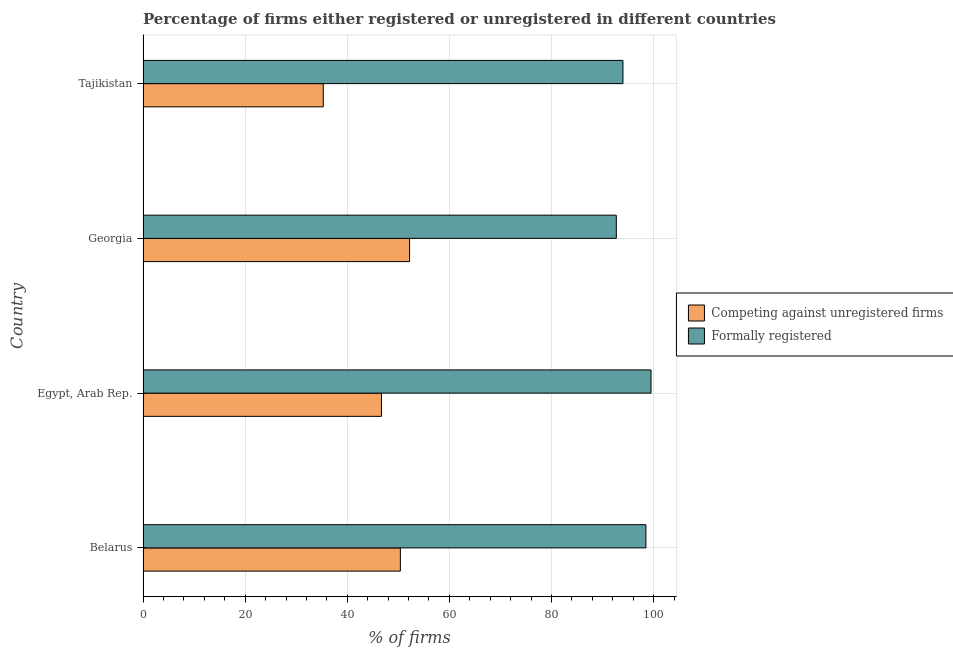How many different coloured bars are there?
Make the answer very short. 2. How many groups of bars are there?
Your answer should be very brief. 4. Are the number of bars per tick equal to the number of legend labels?
Provide a succinct answer. Yes. What is the label of the 1st group of bars from the top?
Ensure brevity in your answer.  Tajikistan. What is the percentage of registered firms in Egypt, Arab Rep.?
Your response must be concise. 46.7. Across all countries, what is the maximum percentage of registered firms?
Keep it short and to the point. 52.2. Across all countries, what is the minimum percentage of formally registered firms?
Provide a short and direct response. 92.7. In which country was the percentage of formally registered firms maximum?
Your answer should be very brief. Egypt, Arab Rep. In which country was the percentage of formally registered firms minimum?
Provide a succinct answer. Georgia. What is the total percentage of registered firms in the graph?
Your answer should be compact. 184.6. What is the difference between the percentage of registered firms in Belarus and that in Tajikistan?
Your answer should be very brief. 15.1. What is the difference between the percentage of formally registered firms in Tajikistan and the percentage of registered firms in Belarus?
Give a very brief answer. 43.6. What is the average percentage of registered firms per country?
Provide a succinct answer. 46.15. What is the difference between the percentage of registered firms and percentage of formally registered firms in Egypt, Arab Rep.?
Offer a terse response. -52.8. In how many countries, is the percentage of formally registered firms greater than 48 %?
Provide a short and direct response. 4. What is the ratio of the percentage of formally registered firms in Belarus to that in Georgia?
Keep it short and to the point. 1.06. Is the percentage of formally registered firms in Egypt, Arab Rep. less than that in Tajikistan?
Offer a very short reply. No. What is the difference between the highest and the lowest percentage of formally registered firms?
Your answer should be compact. 6.8. In how many countries, is the percentage of formally registered firms greater than the average percentage of formally registered firms taken over all countries?
Provide a short and direct response. 2. Is the sum of the percentage of registered firms in Belarus and Georgia greater than the maximum percentage of formally registered firms across all countries?
Provide a succinct answer. Yes. What does the 2nd bar from the top in Belarus represents?
Ensure brevity in your answer.  Competing against unregistered firms. What does the 2nd bar from the bottom in Tajikistan represents?
Make the answer very short. Formally registered. Are all the bars in the graph horizontal?
Your response must be concise. Yes. Are the values on the major ticks of X-axis written in scientific E-notation?
Offer a terse response. No. Does the graph contain any zero values?
Keep it short and to the point. No. Where does the legend appear in the graph?
Make the answer very short. Center right. How many legend labels are there?
Offer a very short reply. 2. How are the legend labels stacked?
Offer a very short reply. Vertical. What is the title of the graph?
Offer a very short reply. Percentage of firms either registered or unregistered in different countries. What is the label or title of the X-axis?
Keep it short and to the point. % of firms. What is the % of firms in Competing against unregistered firms in Belarus?
Provide a succinct answer. 50.4. What is the % of firms in Formally registered in Belarus?
Provide a succinct answer. 98.5. What is the % of firms in Competing against unregistered firms in Egypt, Arab Rep.?
Ensure brevity in your answer.  46.7. What is the % of firms in Formally registered in Egypt, Arab Rep.?
Provide a succinct answer. 99.5. What is the % of firms of Competing against unregistered firms in Georgia?
Offer a terse response. 52.2. What is the % of firms of Formally registered in Georgia?
Make the answer very short. 92.7. What is the % of firms in Competing against unregistered firms in Tajikistan?
Give a very brief answer. 35.3. What is the % of firms of Formally registered in Tajikistan?
Your response must be concise. 94. Across all countries, what is the maximum % of firms of Competing against unregistered firms?
Your answer should be very brief. 52.2. Across all countries, what is the maximum % of firms in Formally registered?
Your answer should be compact. 99.5. Across all countries, what is the minimum % of firms in Competing against unregistered firms?
Your response must be concise. 35.3. Across all countries, what is the minimum % of firms in Formally registered?
Provide a succinct answer. 92.7. What is the total % of firms in Competing against unregistered firms in the graph?
Provide a short and direct response. 184.6. What is the total % of firms in Formally registered in the graph?
Your response must be concise. 384.7. What is the difference between the % of firms in Formally registered in Belarus and that in Egypt, Arab Rep.?
Ensure brevity in your answer.  -1. What is the difference between the % of firms in Formally registered in Belarus and that in Tajikistan?
Offer a very short reply. 4.5. What is the difference between the % of firms of Formally registered in Egypt, Arab Rep. and that in Georgia?
Keep it short and to the point. 6.8. What is the difference between the % of firms in Formally registered in Egypt, Arab Rep. and that in Tajikistan?
Give a very brief answer. 5.5. What is the difference between the % of firms of Competing against unregistered firms in Belarus and the % of firms of Formally registered in Egypt, Arab Rep.?
Give a very brief answer. -49.1. What is the difference between the % of firms in Competing against unregistered firms in Belarus and the % of firms in Formally registered in Georgia?
Give a very brief answer. -42.3. What is the difference between the % of firms in Competing against unregistered firms in Belarus and the % of firms in Formally registered in Tajikistan?
Your answer should be compact. -43.6. What is the difference between the % of firms in Competing against unregistered firms in Egypt, Arab Rep. and the % of firms in Formally registered in Georgia?
Your answer should be compact. -46. What is the difference between the % of firms in Competing against unregistered firms in Egypt, Arab Rep. and the % of firms in Formally registered in Tajikistan?
Offer a terse response. -47.3. What is the difference between the % of firms in Competing against unregistered firms in Georgia and the % of firms in Formally registered in Tajikistan?
Make the answer very short. -41.8. What is the average % of firms of Competing against unregistered firms per country?
Provide a succinct answer. 46.15. What is the average % of firms of Formally registered per country?
Your response must be concise. 96.17. What is the difference between the % of firms in Competing against unregistered firms and % of firms in Formally registered in Belarus?
Your answer should be compact. -48.1. What is the difference between the % of firms of Competing against unregistered firms and % of firms of Formally registered in Egypt, Arab Rep.?
Your response must be concise. -52.8. What is the difference between the % of firms in Competing against unregistered firms and % of firms in Formally registered in Georgia?
Provide a short and direct response. -40.5. What is the difference between the % of firms of Competing against unregistered firms and % of firms of Formally registered in Tajikistan?
Ensure brevity in your answer.  -58.7. What is the ratio of the % of firms in Competing against unregistered firms in Belarus to that in Egypt, Arab Rep.?
Your answer should be very brief. 1.08. What is the ratio of the % of firms of Competing against unregistered firms in Belarus to that in Georgia?
Provide a succinct answer. 0.97. What is the ratio of the % of firms in Formally registered in Belarus to that in Georgia?
Your response must be concise. 1.06. What is the ratio of the % of firms in Competing against unregistered firms in Belarus to that in Tajikistan?
Offer a terse response. 1.43. What is the ratio of the % of firms of Formally registered in Belarus to that in Tajikistan?
Your answer should be compact. 1.05. What is the ratio of the % of firms in Competing against unregistered firms in Egypt, Arab Rep. to that in Georgia?
Provide a short and direct response. 0.89. What is the ratio of the % of firms of Formally registered in Egypt, Arab Rep. to that in Georgia?
Your answer should be very brief. 1.07. What is the ratio of the % of firms of Competing against unregistered firms in Egypt, Arab Rep. to that in Tajikistan?
Provide a succinct answer. 1.32. What is the ratio of the % of firms in Formally registered in Egypt, Arab Rep. to that in Tajikistan?
Keep it short and to the point. 1.06. What is the ratio of the % of firms of Competing against unregistered firms in Georgia to that in Tajikistan?
Your answer should be compact. 1.48. What is the ratio of the % of firms of Formally registered in Georgia to that in Tajikistan?
Keep it short and to the point. 0.99. What is the difference between the highest and the lowest % of firms of Competing against unregistered firms?
Ensure brevity in your answer.  16.9. 